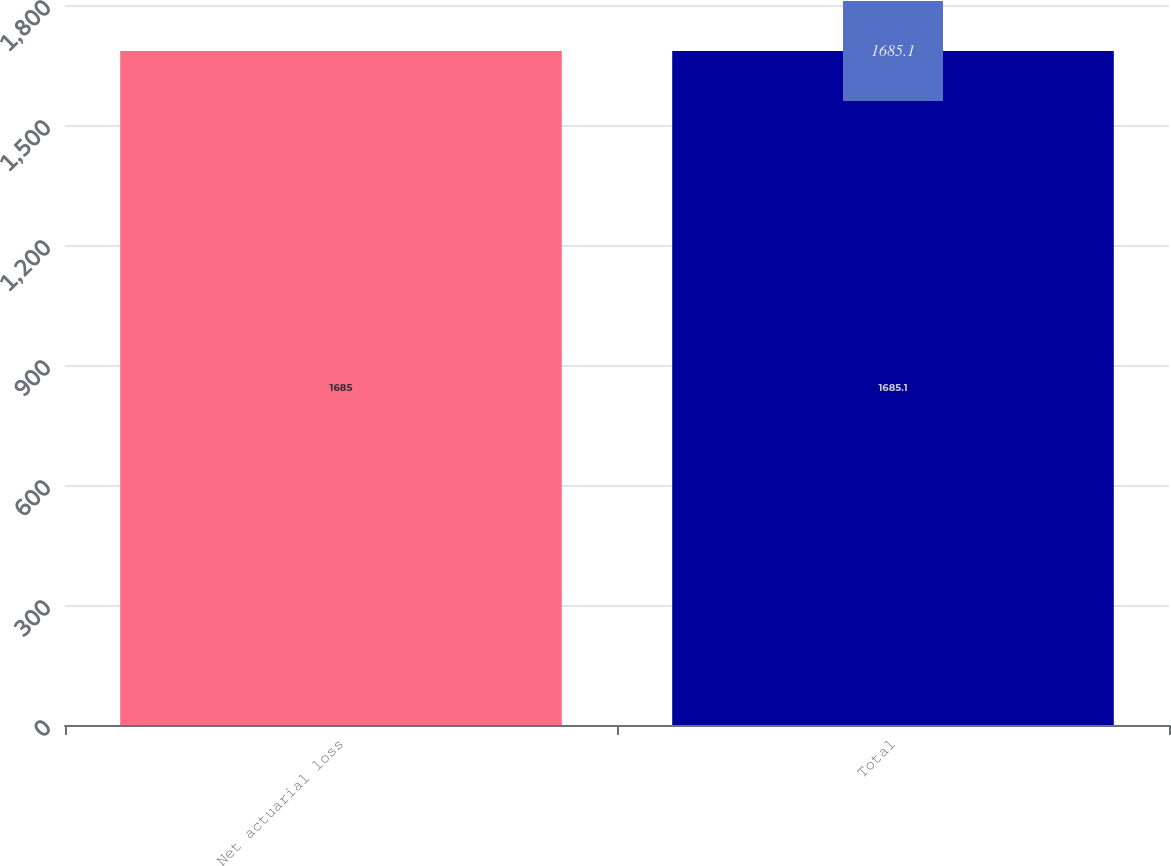Convert chart to OTSL. <chart><loc_0><loc_0><loc_500><loc_500><bar_chart><fcel>Net actuarial loss<fcel>Total<nl><fcel>1685<fcel>1685.1<nl></chart> 